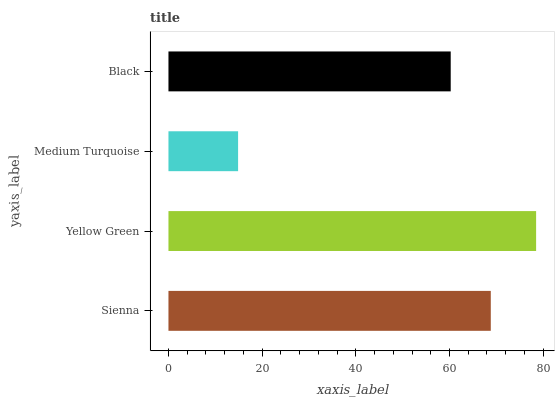Is Medium Turquoise the minimum?
Answer yes or no. Yes. Is Yellow Green the maximum?
Answer yes or no. Yes. Is Yellow Green the minimum?
Answer yes or no. No. Is Medium Turquoise the maximum?
Answer yes or no. No. Is Yellow Green greater than Medium Turquoise?
Answer yes or no. Yes. Is Medium Turquoise less than Yellow Green?
Answer yes or no. Yes. Is Medium Turquoise greater than Yellow Green?
Answer yes or no. No. Is Yellow Green less than Medium Turquoise?
Answer yes or no. No. Is Sienna the high median?
Answer yes or no. Yes. Is Black the low median?
Answer yes or no. Yes. Is Yellow Green the high median?
Answer yes or no. No. Is Medium Turquoise the low median?
Answer yes or no. No. 